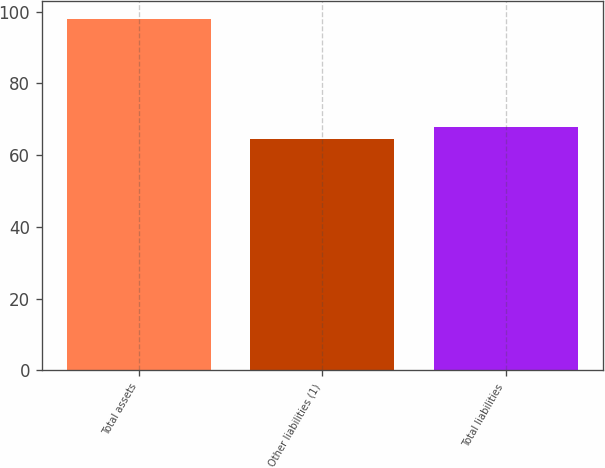Convert chart. <chart><loc_0><loc_0><loc_500><loc_500><bar_chart><fcel>Total assets<fcel>Other liabilities (1)<fcel>Total liabilities<nl><fcel>98.1<fcel>64.5<fcel>67.86<nl></chart> 